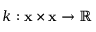<formula> <loc_0><loc_0><loc_500><loc_500>k \colon x \times x \rightarrow \mathbb { R }</formula> 